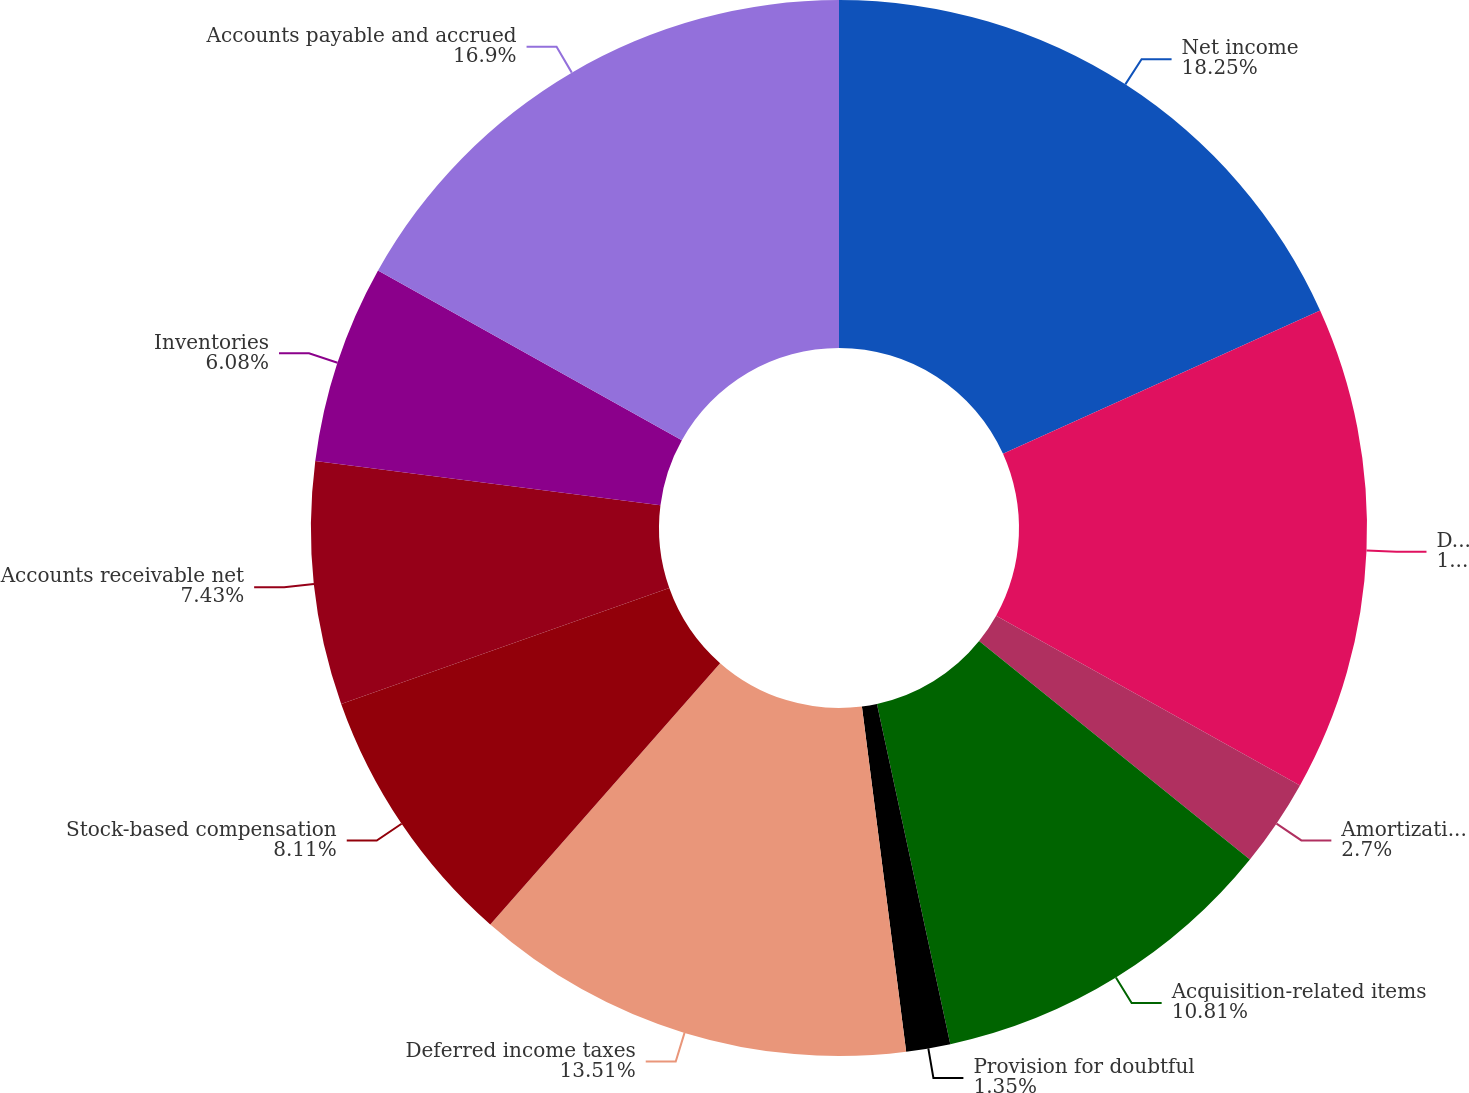<chart> <loc_0><loc_0><loc_500><loc_500><pie_chart><fcel>Net income<fcel>Depreciation and amortization<fcel>Amortization of debt discount<fcel>Acquisition-related items<fcel>Provision for doubtful<fcel>Deferred income taxes<fcel>Stock-based compensation<fcel>Accounts receivable net<fcel>Inventories<fcel>Accounts payable and accrued<nl><fcel>18.24%<fcel>14.86%<fcel>2.7%<fcel>10.81%<fcel>1.35%<fcel>13.51%<fcel>8.11%<fcel>7.43%<fcel>6.08%<fcel>16.89%<nl></chart> 